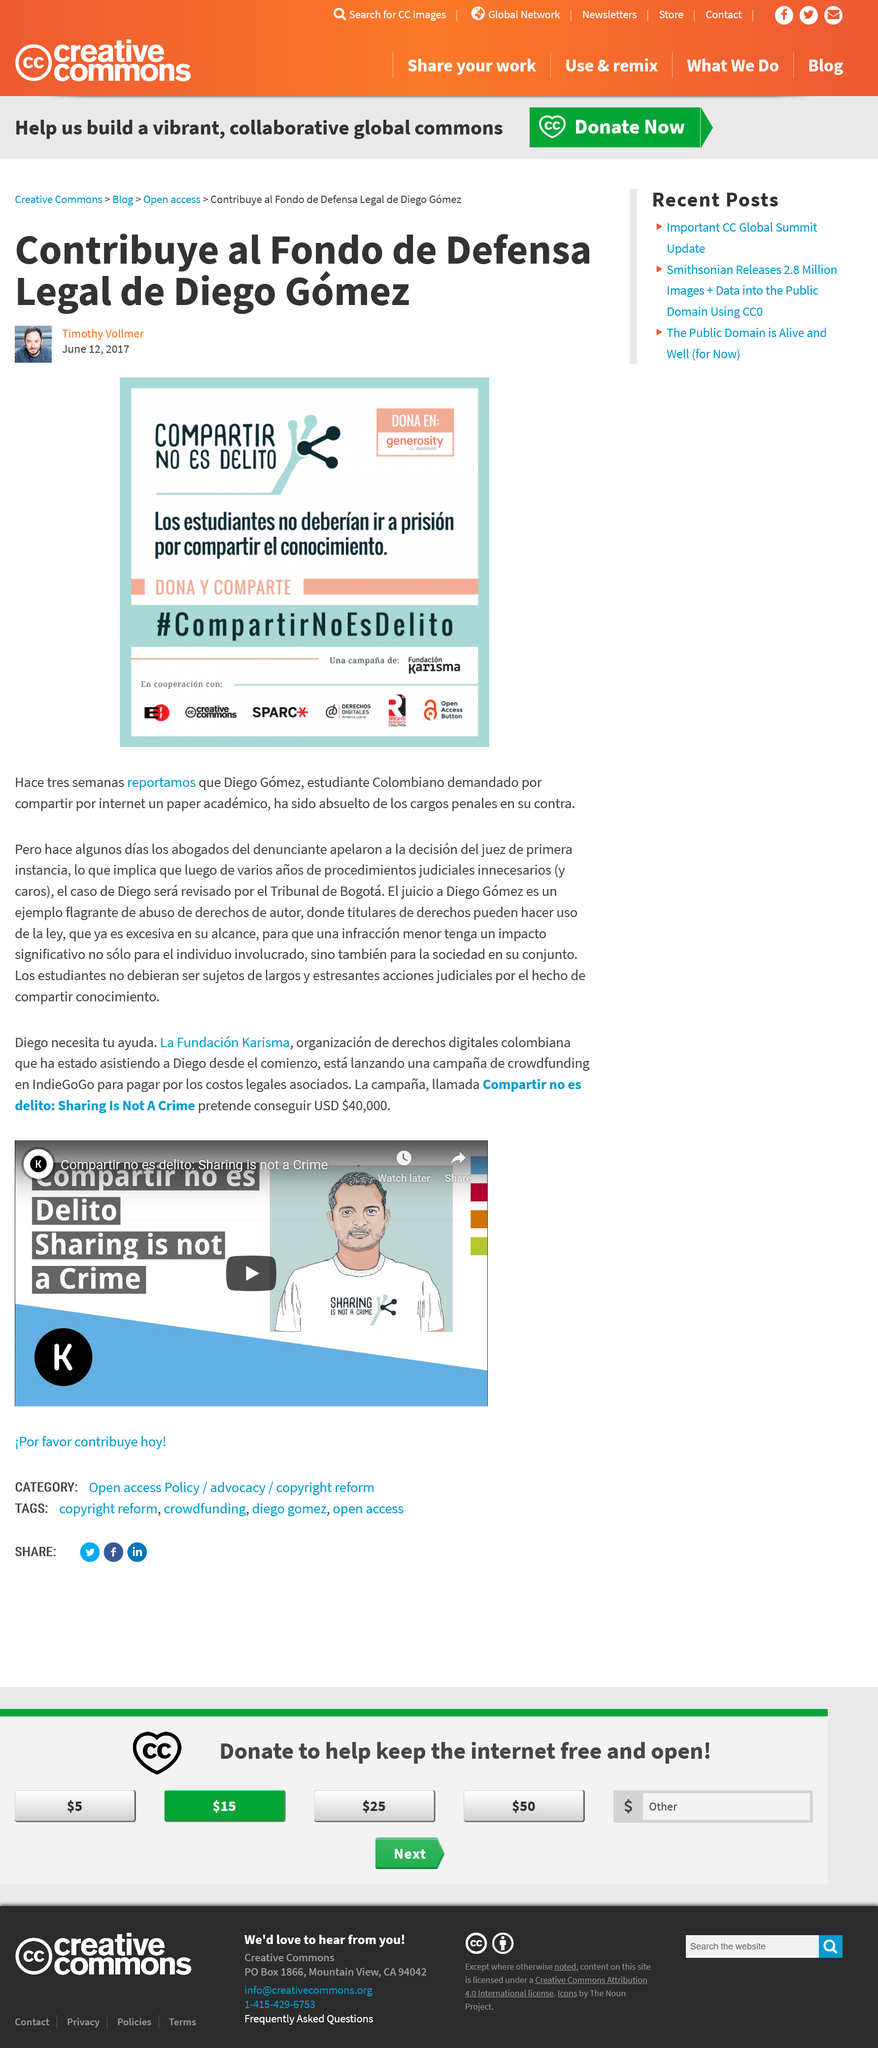Point out several critical features in this image. The article was written in 2017. Creative Commons is contributing to the cause and is, in fact, Diego Gómez is the subject of the article. 